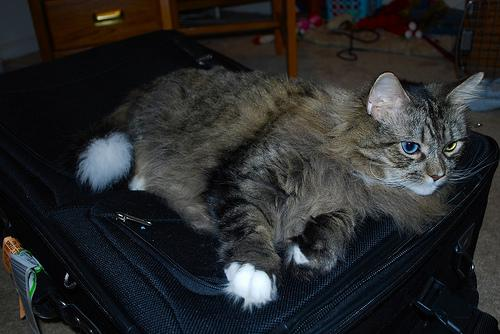Question: what is the cat sitting on?
Choices:
A. The floor.
B. A chair.
C. Suitcase.
D. A counter.
Answer with the letter. Answer: C Question: what is the left eye color?
Choices:
A. Blue.
B. Brown.
C. Black.
D. Gray.
Answer with the letter. Answer: A Question: who is in the room?
Choices:
A. A man.
B. A woman.
C. A child.
D. Cat.
Answer with the letter. Answer: D 